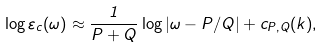<formula> <loc_0><loc_0><loc_500><loc_500>\log \varepsilon _ { c } ( \omega ) \approx \frac { 1 } { P + Q } \log | \omega - P / Q | + c _ { P , Q } ( k ) ,</formula> 